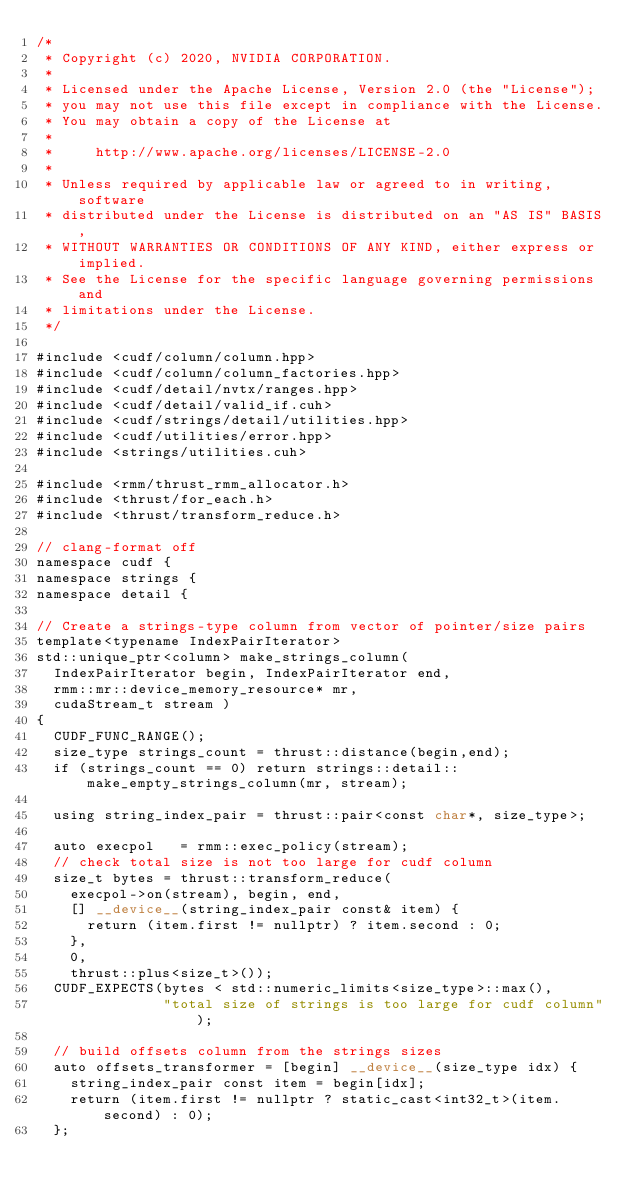<code> <loc_0><loc_0><loc_500><loc_500><_Cuda_>/*
 * Copyright (c) 2020, NVIDIA CORPORATION.
 *
 * Licensed under the Apache License, Version 2.0 (the "License");
 * you may not use this file except in compliance with the License.
 * You may obtain a copy of the License at
 *
 *     http://www.apache.org/licenses/LICENSE-2.0
 *
 * Unless required by applicable law or agreed to in writing, software
 * distributed under the License is distributed on an "AS IS" BASIS,
 * WITHOUT WARRANTIES OR CONDITIONS OF ANY KIND, either express or implied.
 * See the License for the specific language governing permissions and
 * limitations under the License.
 */

#include <cudf/column/column.hpp>
#include <cudf/column/column_factories.hpp>
#include <cudf/detail/nvtx/ranges.hpp>
#include <cudf/detail/valid_if.cuh>
#include <cudf/strings/detail/utilities.hpp>
#include <cudf/utilities/error.hpp>
#include <strings/utilities.cuh>

#include <rmm/thrust_rmm_allocator.h>
#include <thrust/for_each.h>
#include <thrust/transform_reduce.h>

// clang-format off
namespace cudf {
namespace strings {
namespace detail {

// Create a strings-type column from vector of pointer/size pairs
template<typename IndexPairIterator>
std::unique_ptr<column> make_strings_column(
  IndexPairIterator begin, IndexPairIterator end,
  rmm::mr::device_memory_resource* mr,
  cudaStream_t stream ) 
{
  CUDF_FUNC_RANGE();
  size_type strings_count = thrust::distance(begin,end);
  if (strings_count == 0) return strings::detail::make_empty_strings_column(mr, stream);

  using string_index_pair = thrust::pair<const char*, size_type>;

  auto execpol   = rmm::exec_policy(stream);
  // check total size is not too large for cudf column
  size_t bytes = thrust::transform_reduce(
    execpol->on(stream), begin, end,
    [] __device__(string_index_pair const& item) {
      return (item.first != nullptr) ? item.second : 0;
    },
    0,
    thrust::plus<size_t>());
  CUDF_EXPECTS(bytes < std::numeric_limits<size_type>::max(),
               "total size of strings is too large for cudf column");

  // build offsets column from the strings sizes
  auto offsets_transformer = [begin] __device__(size_type idx) {
    string_index_pair const item = begin[idx];
    return (item.first != nullptr ? static_cast<int32_t>(item.second) : 0);
  };</code> 